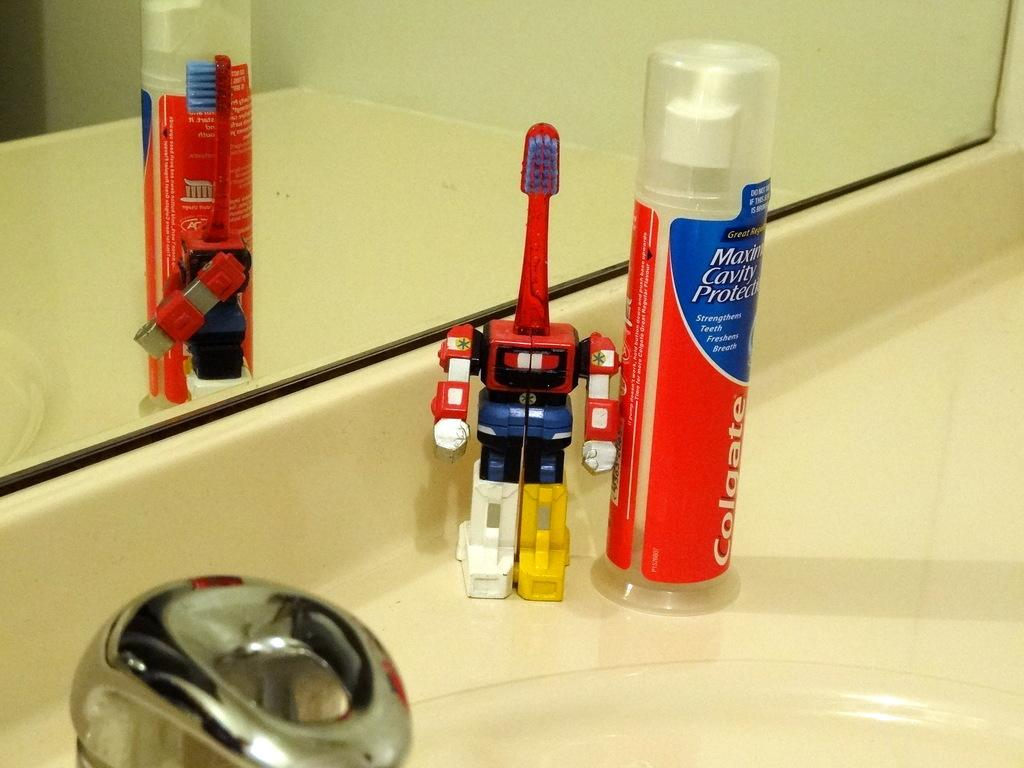<image>
Write a terse but informative summary of the picture. bathroom countertop with colgate maximum cavity protection toothpaste and red toothbrush in a plastic robot holder 